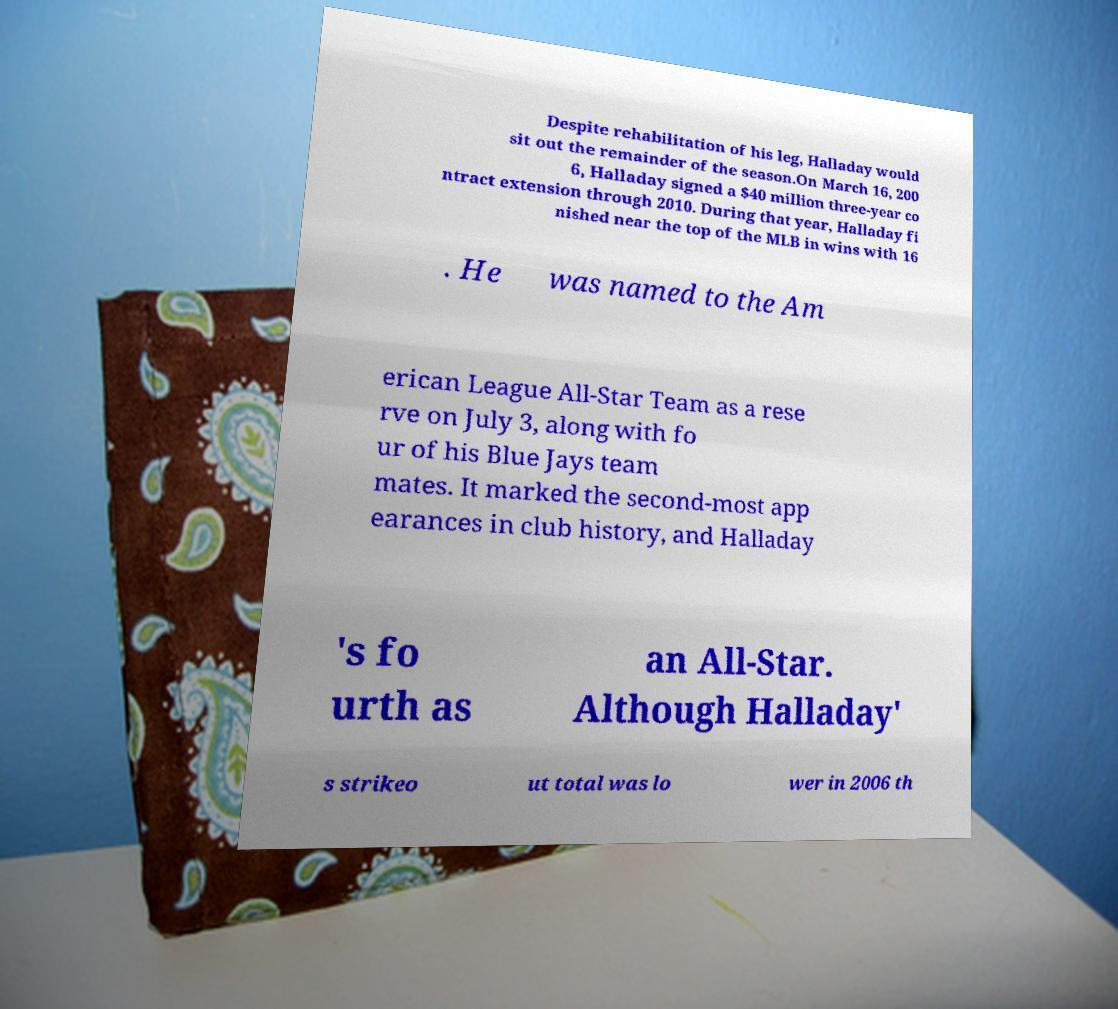There's text embedded in this image that I need extracted. Can you transcribe it verbatim? Despite rehabilitation of his leg, Halladay would sit out the remainder of the season.On March 16, 200 6, Halladay signed a $40 million three-year co ntract extension through 2010. During that year, Halladay fi nished near the top of the MLB in wins with 16 . He was named to the Am erican League All-Star Team as a rese rve on July 3, along with fo ur of his Blue Jays team mates. It marked the second-most app earances in club history, and Halladay 's fo urth as an All-Star. Although Halladay' s strikeo ut total was lo wer in 2006 th 